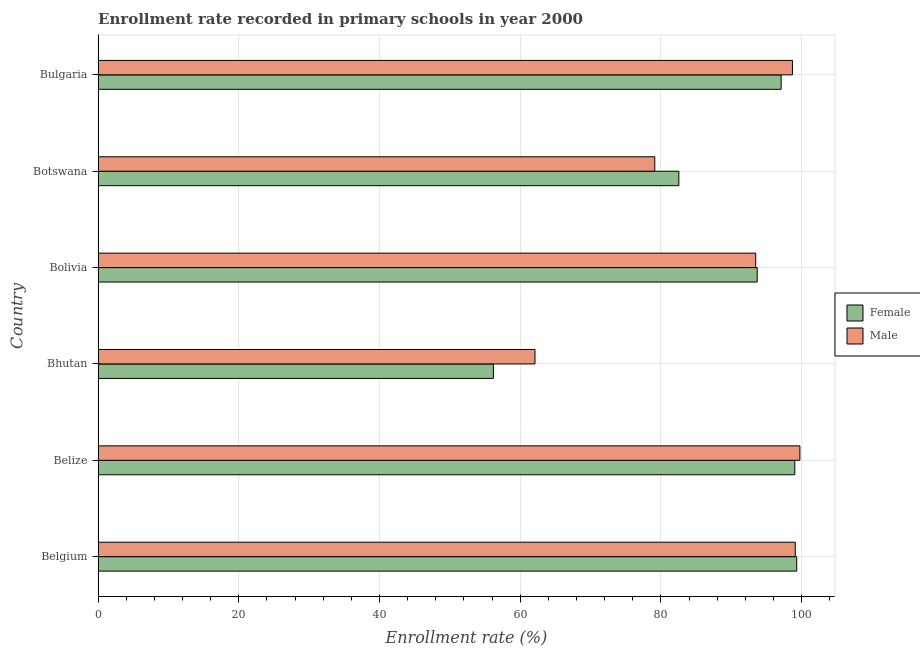How many different coloured bars are there?
Your answer should be compact. 2. Are the number of bars per tick equal to the number of legend labels?
Offer a very short reply. Yes. How many bars are there on the 6th tick from the top?
Your answer should be compact. 2. What is the enrollment rate of male students in Bolivia?
Make the answer very short. 93.47. Across all countries, what is the maximum enrollment rate of female students?
Offer a terse response. 99.3. Across all countries, what is the minimum enrollment rate of female students?
Ensure brevity in your answer.  56.19. In which country was the enrollment rate of female students maximum?
Give a very brief answer. Belgium. In which country was the enrollment rate of female students minimum?
Your answer should be very brief. Bhutan. What is the total enrollment rate of female students in the graph?
Your response must be concise. 527.82. What is the difference between the enrollment rate of male students in Belgium and that in Bulgaria?
Keep it short and to the point. 0.4. What is the difference between the enrollment rate of female students in Bulgaria and the enrollment rate of male students in Belize?
Give a very brief answer. -2.66. What is the average enrollment rate of male students per country?
Offer a terse response. 88.7. What is the difference between the enrollment rate of female students and enrollment rate of male students in Belgium?
Offer a very short reply. 0.21. What is the ratio of the enrollment rate of female students in Belize to that in Bhutan?
Your response must be concise. 1.76. Is the enrollment rate of female students in Belgium less than that in Botswana?
Provide a short and direct response. No. What is the difference between the highest and the second highest enrollment rate of male students?
Ensure brevity in your answer.  0.66. What is the difference between the highest and the lowest enrollment rate of female students?
Provide a succinct answer. 43.11. In how many countries, is the enrollment rate of male students greater than the average enrollment rate of male students taken over all countries?
Provide a short and direct response. 4. What does the 2nd bar from the top in Bulgaria represents?
Offer a very short reply. Female. Are all the bars in the graph horizontal?
Offer a terse response. Yes. How many countries are there in the graph?
Give a very brief answer. 6. What is the difference between two consecutive major ticks on the X-axis?
Ensure brevity in your answer.  20. How many legend labels are there?
Give a very brief answer. 2. What is the title of the graph?
Keep it short and to the point. Enrollment rate recorded in primary schools in year 2000. What is the label or title of the X-axis?
Provide a succinct answer. Enrollment rate (%). What is the Enrollment rate (%) in Female in Belgium?
Your response must be concise. 99.3. What is the Enrollment rate (%) in Male in Belgium?
Make the answer very short. 99.09. What is the Enrollment rate (%) of Female in Belize?
Make the answer very short. 99.03. What is the Enrollment rate (%) in Male in Belize?
Offer a terse response. 99.75. What is the Enrollment rate (%) in Female in Bhutan?
Provide a succinct answer. 56.19. What is the Enrollment rate (%) of Male in Bhutan?
Provide a succinct answer. 62.1. What is the Enrollment rate (%) of Female in Bolivia?
Your answer should be compact. 93.68. What is the Enrollment rate (%) in Male in Bolivia?
Make the answer very short. 93.47. What is the Enrollment rate (%) of Female in Botswana?
Your answer should be very brief. 82.54. What is the Enrollment rate (%) of Male in Botswana?
Make the answer very short. 79.12. What is the Enrollment rate (%) of Female in Bulgaria?
Give a very brief answer. 97.08. What is the Enrollment rate (%) of Male in Bulgaria?
Your answer should be very brief. 98.69. Across all countries, what is the maximum Enrollment rate (%) of Female?
Ensure brevity in your answer.  99.3. Across all countries, what is the maximum Enrollment rate (%) in Male?
Provide a succinct answer. 99.75. Across all countries, what is the minimum Enrollment rate (%) in Female?
Provide a short and direct response. 56.19. Across all countries, what is the minimum Enrollment rate (%) of Male?
Provide a short and direct response. 62.1. What is the total Enrollment rate (%) of Female in the graph?
Make the answer very short. 527.82. What is the total Enrollment rate (%) of Male in the graph?
Give a very brief answer. 532.22. What is the difference between the Enrollment rate (%) of Female in Belgium and that in Belize?
Your answer should be compact. 0.27. What is the difference between the Enrollment rate (%) in Male in Belgium and that in Belize?
Give a very brief answer. -0.66. What is the difference between the Enrollment rate (%) of Female in Belgium and that in Bhutan?
Keep it short and to the point. 43.11. What is the difference between the Enrollment rate (%) in Male in Belgium and that in Bhutan?
Your answer should be compact. 36.99. What is the difference between the Enrollment rate (%) of Female in Belgium and that in Bolivia?
Offer a terse response. 5.62. What is the difference between the Enrollment rate (%) in Male in Belgium and that in Bolivia?
Offer a very short reply. 5.62. What is the difference between the Enrollment rate (%) of Female in Belgium and that in Botswana?
Provide a short and direct response. 16.75. What is the difference between the Enrollment rate (%) of Male in Belgium and that in Botswana?
Keep it short and to the point. 19.97. What is the difference between the Enrollment rate (%) in Female in Belgium and that in Bulgaria?
Ensure brevity in your answer.  2.21. What is the difference between the Enrollment rate (%) in Male in Belgium and that in Bulgaria?
Ensure brevity in your answer.  0.4. What is the difference between the Enrollment rate (%) of Female in Belize and that in Bhutan?
Offer a very short reply. 42.84. What is the difference between the Enrollment rate (%) in Male in Belize and that in Bhutan?
Offer a very short reply. 37.65. What is the difference between the Enrollment rate (%) in Female in Belize and that in Bolivia?
Your answer should be compact. 5.35. What is the difference between the Enrollment rate (%) of Male in Belize and that in Bolivia?
Your answer should be compact. 6.28. What is the difference between the Enrollment rate (%) of Female in Belize and that in Botswana?
Provide a succinct answer. 16.48. What is the difference between the Enrollment rate (%) of Male in Belize and that in Botswana?
Provide a succinct answer. 20.62. What is the difference between the Enrollment rate (%) of Female in Belize and that in Bulgaria?
Provide a succinct answer. 1.94. What is the difference between the Enrollment rate (%) in Male in Belize and that in Bulgaria?
Your response must be concise. 1.06. What is the difference between the Enrollment rate (%) of Female in Bhutan and that in Bolivia?
Your answer should be very brief. -37.49. What is the difference between the Enrollment rate (%) of Male in Bhutan and that in Bolivia?
Make the answer very short. -31.37. What is the difference between the Enrollment rate (%) of Female in Bhutan and that in Botswana?
Your answer should be compact. -26.36. What is the difference between the Enrollment rate (%) in Male in Bhutan and that in Botswana?
Offer a very short reply. -17.02. What is the difference between the Enrollment rate (%) of Female in Bhutan and that in Bulgaria?
Make the answer very short. -40.9. What is the difference between the Enrollment rate (%) in Male in Bhutan and that in Bulgaria?
Your answer should be very brief. -36.59. What is the difference between the Enrollment rate (%) of Female in Bolivia and that in Botswana?
Keep it short and to the point. 11.14. What is the difference between the Enrollment rate (%) in Male in Bolivia and that in Botswana?
Provide a succinct answer. 14.35. What is the difference between the Enrollment rate (%) in Female in Bolivia and that in Bulgaria?
Give a very brief answer. -3.4. What is the difference between the Enrollment rate (%) in Male in Bolivia and that in Bulgaria?
Provide a short and direct response. -5.22. What is the difference between the Enrollment rate (%) of Female in Botswana and that in Bulgaria?
Your answer should be very brief. -14.54. What is the difference between the Enrollment rate (%) in Male in Botswana and that in Bulgaria?
Your answer should be compact. -19.56. What is the difference between the Enrollment rate (%) in Female in Belgium and the Enrollment rate (%) in Male in Belize?
Your response must be concise. -0.45. What is the difference between the Enrollment rate (%) of Female in Belgium and the Enrollment rate (%) of Male in Bhutan?
Offer a terse response. 37.2. What is the difference between the Enrollment rate (%) of Female in Belgium and the Enrollment rate (%) of Male in Bolivia?
Your answer should be very brief. 5.83. What is the difference between the Enrollment rate (%) in Female in Belgium and the Enrollment rate (%) in Male in Botswana?
Give a very brief answer. 20.17. What is the difference between the Enrollment rate (%) in Female in Belgium and the Enrollment rate (%) in Male in Bulgaria?
Make the answer very short. 0.61. What is the difference between the Enrollment rate (%) in Female in Belize and the Enrollment rate (%) in Male in Bhutan?
Provide a short and direct response. 36.93. What is the difference between the Enrollment rate (%) in Female in Belize and the Enrollment rate (%) in Male in Bolivia?
Your answer should be very brief. 5.56. What is the difference between the Enrollment rate (%) of Female in Belize and the Enrollment rate (%) of Male in Botswana?
Your response must be concise. 19.9. What is the difference between the Enrollment rate (%) of Female in Belize and the Enrollment rate (%) of Male in Bulgaria?
Your answer should be compact. 0.34. What is the difference between the Enrollment rate (%) of Female in Bhutan and the Enrollment rate (%) of Male in Bolivia?
Offer a very short reply. -37.28. What is the difference between the Enrollment rate (%) of Female in Bhutan and the Enrollment rate (%) of Male in Botswana?
Your answer should be very brief. -22.94. What is the difference between the Enrollment rate (%) in Female in Bhutan and the Enrollment rate (%) in Male in Bulgaria?
Offer a terse response. -42.5. What is the difference between the Enrollment rate (%) of Female in Bolivia and the Enrollment rate (%) of Male in Botswana?
Your answer should be compact. 14.56. What is the difference between the Enrollment rate (%) in Female in Bolivia and the Enrollment rate (%) in Male in Bulgaria?
Make the answer very short. -5.01. What is the difference between the Enrollment rate (%) in Female in Botswana and the Enrollment rate (%) in Male in Bulgaria?
Provide a short and direct response. -16.15. What is the average Enrollment rate (%) of Female per country?
Provide a short and direct response. 87.97. What is the average Enrollment rate (%) in Male per country?
Your response must be concise. 88.7. What is the difference between the Enrollment rate (%) in Female and Enrollment rate (%) in Male in Belgium?
Provide a short and direct response. 0.21. What is the difference between the Enrollment rate (%) of Female and Enrollment rate (%) of Male in Belize?
Offer a terse response. -0.72. What is the difference between the Enrollment rate (%) in Female and Enrollment rate (%) in Male in Bhutan?
Make the answer very short. -5.91. What is the difference between the Enrollment rate (%) in Female and Enrollment rate (%) in Male in Bolivia?
Provide a succinct answer. 0.21. What is the difference between the Enrollment rate (%) in Female and Enrollment rate (%) in Male in Botswana?
Your answer should be very brief. 3.42. What is the difference between the Enrollment rate (%) of Female and Enrollment rate (%) of Male in Bulgaria?
Offer a very short reply. -1.6. What is the ratio of the Enrollment rate (%) in Female in Belgium to that in Belize?
Offer a terse response. 1. What is the ratio of the Enrollment rate (%) in Male in Belgium to that in Belize?
Offer a terse response. 0.99. What is the ratio of the Enrollment rate (%) of Female in Belgium to that in Bhutan?
Your answer should be very brief. 1.77. What is the ratio of the Enrollment rate (%) in Male in Belgium to that in Bhutan?
Keep it short and to the point. 1.6. What is the ratio of the Enrollment rate (%) of Female in Belgium to that in Bolivia?
Offer a terse response. 1.06. What is the ratio of the Enrollment rate (%) of Male in Belgium to that in Bolivia?
Your response must be concise. 1.06. What is the ratio of the Enrollment rate (%) in Female in Belgium to that in Botswana?
Offer a terse response. 1.2. What is the ratio of the Enrollment rate (%) in Male in Belgium to that in Botswana?
Make the answer very short. 1.25. What is the ratio of the Enrollment rate (%) of Female in Belgium to that in Bulgaria?
Offer a terse response. 1.02. What is the ratio of the Enrollment rate (%) of Female in Belize to that in Bhutan?
Your answer should be compact. 1.76. What is the ratio of the Enrollment rate (%) of Male in Belize to that in Bhutan?
Make the answer very short. 1.61. What is the ratio of the Enrollment rate (%) in Female in Belize to that in Bolivia?
Give a very brief answer. 1.06. What is the ratio of the Enrollment rate (%) of Male in Belize to that in Bolivia?
Keep it short and to the point. 1.07. What is the ratio of the Enrollment rate (%) in Female in Belize to that in Botswana?
Offer a terse response. 1.2. What is the ratio of the Enrollment rate (%) of Male in Belize to that in Botswana?
Offer a terse response. 1.26. What is the ratio of the Enrollment rate (%) of Male in Belize to that in Bulgaria?
Your response must be concise. 1.01. What is the ratio of the Enrollment rate (%) in Female in Bhutan to that in Bolivia?
Provide a short and direct response. 0.6. What is the ratio of the Enrollment rate (%) of Male in Bhutan to that in Bolivia?
Offer a very short reply. 0.66. What is the ratio of the Enrollment rate (%) of Female in Bhutan to that in Botswana?
Keep it short and to the point. 0.68. What is the ratio of the Enrollment rate (%) in Male in Bhutan to that in Botswana?
Your response must be concise. 0.78. What is the ratio of the Enrollment rate (%) of Female in Bhutan to that in Bulgaria?
Offer a terse response. 0.58. What is the ratio of the Enrollment rate (%) in Male in Bhutan to that in Bulgaria?
Offer a very short reply. 0.63. What is the ratio of the Enrollment rate (%) of Female in Bolivia to that in Botswana?
Offer a terse response. 1.13. What is the ratio of the Enrollment rate (%) in Male in Bolivia to that in Botswana?
Make the answer very short. 1.18. What is the ratio of the Enrollment rate (%) of Male in Bolivia to that in Bulgaria?
Make the answer very short. 0.95. What is the ratio of the Enrollment rate (%) of Female in Botswana to that in Bulgaria?
Keep it short and to the point. 0.85. What is the ratio of the Enrollment rate (%) in Male in Botswana to that in Bulgaria?
Make the answer very short. 0.8. What is the difference between the highest and the second highest Enrollment rate (%) of Female?
Make the answer very short. 0.27. What is the difference between the highest and the second highest Enrollment rate (%) in Male?
Keep it short and to the point. 0.66. What is the difference between the highest and the lowest Enrollment rate (%) in Female?
Ensure brevity in your answer.  43.11. What is the difference between the highest and the lowest Enrollment rate (%) of Male?
Give a very brief answer. 37.65. 